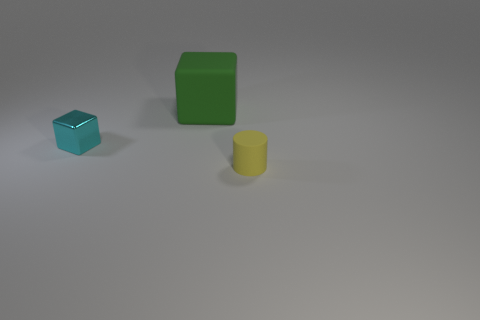Subtract all green blocks. How many blocks are left? 1 Add 2 cyan metal blocks. How many objects exist? 5 Subtract all cubes. How many objects are left? 1 Subtract 1 blocks. How many blocks are left? 1 Subtract all matte cylinders. Subtract all cylinders. How many objects are left? 1 Add 1 small yellow rubber cylinders. How many small yellow rubber cylinders are left? 2 Add 1 cyan metallic blocks. How many cyan metallic blocks exist? 2 Subtract 0 purple blocks. How many objects are left? 3 Subtract all red cylinders. Subtract all blue cubes. How many cylinders are left? 1 